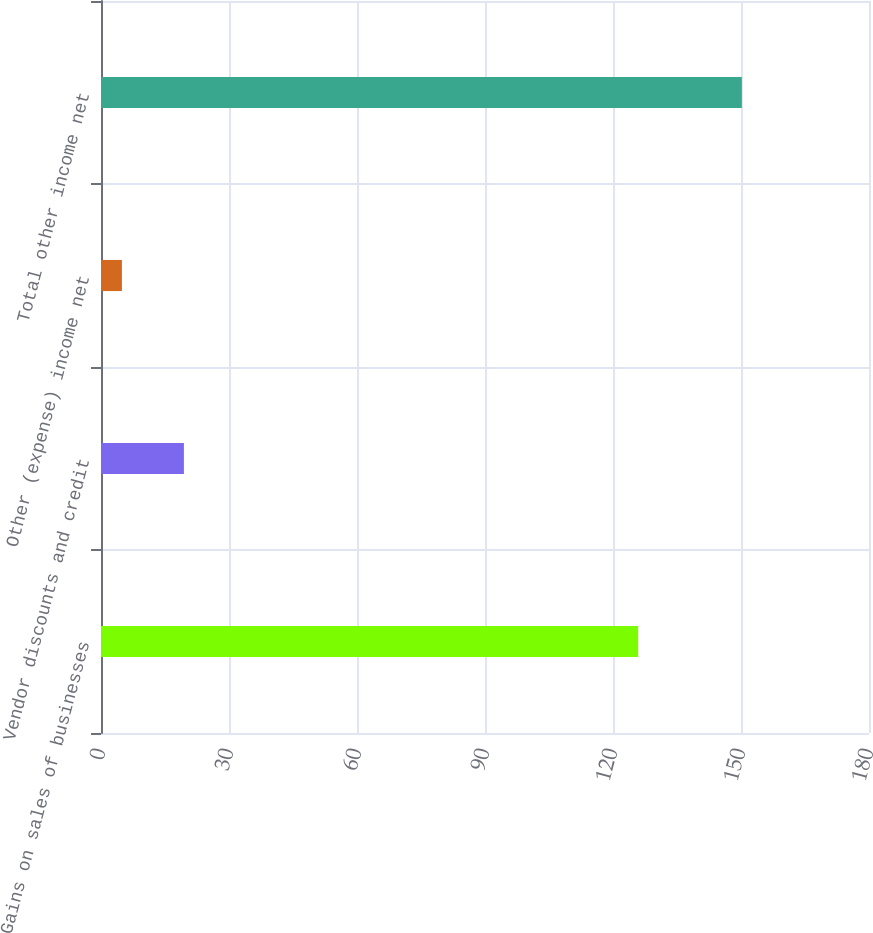Convert chart. <chart><loc_0><loc_0><loc_500><loc_500><bar_chart><fcel>Gains on sales of businesses<fcel>Vendor discounts and credit<fcel>Other (expense) income net<fcel>Total other income net<nl><fcel>125.9<fcel>19.43<fcel>4.9<fcel>150.2<nl></chart> 